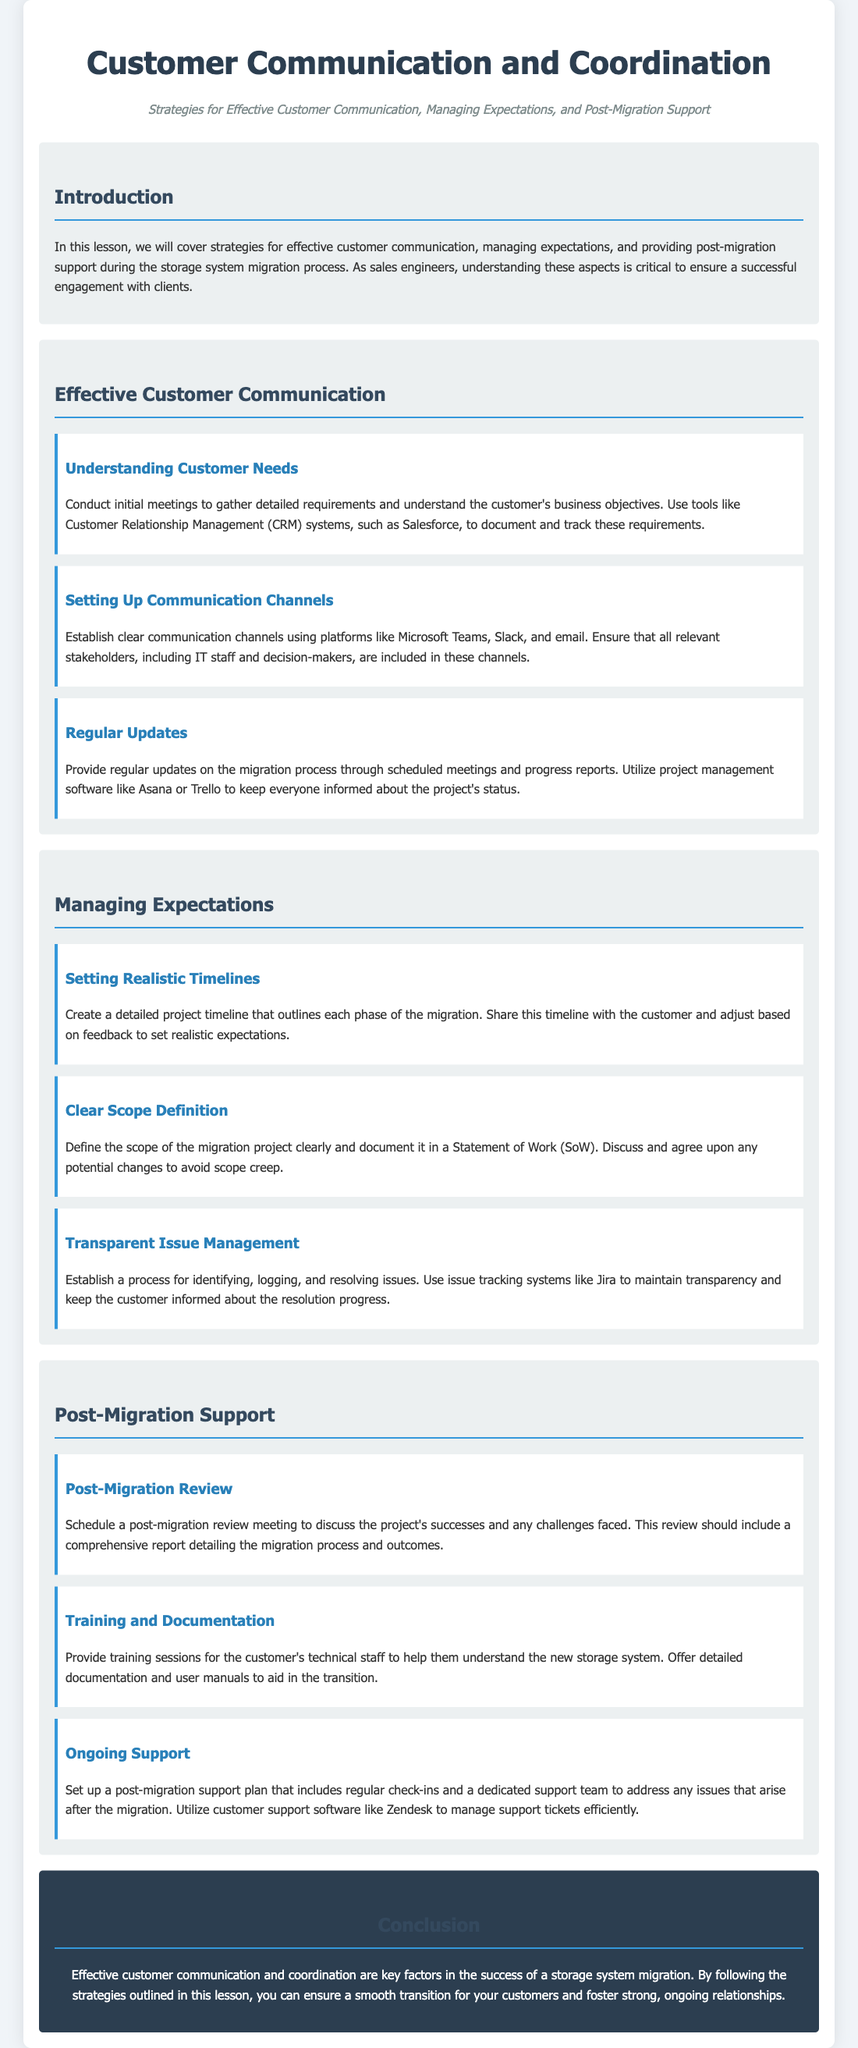what is the title of the lesson plan? The title of the lesson plan is the main heading at the top of the document.
Answer: Customer Communication and Coordination what are the platforms mentioned for setting up communication channels? The platforms are listed in the section about setting up communication channels under effective customer communication.
Answer: Microsoft Teams, Slack, email what is the purpose of the post-migration review meeting? The purpose is described in the section on post-migration support regarding the review meeting.
Answer: Discuss the project's successes and any challenges faced what software is recommended for tracking issues? This is specified in the section about transparent issue management under managing expectations.
Answer: Jira what strategy helps to gather detailed customer requirements? This strategy is described in the subsection under effective customer communication.
Answer: Conduct initial meetings what is included in the post-migration support plan? This is mentioned in the subsection about ongoing support within post-migration support.
Answer: Regular check-ins and a dedicated support team what tool is suggested for managing support tickets efficiently? This tool is highlighted in the section about ongoing support in post-migration support.
Answer: Zendesk how is the section on setting realistic timelines characterized? This characterization can be found in the managing expectations section where realistic timelines are discussed.
Answer: Create a detailed project timeline what color is used for the background of the conclusion section? This detail refers to the visual style of the conclusion section in the document.
Answer: Dark blue 